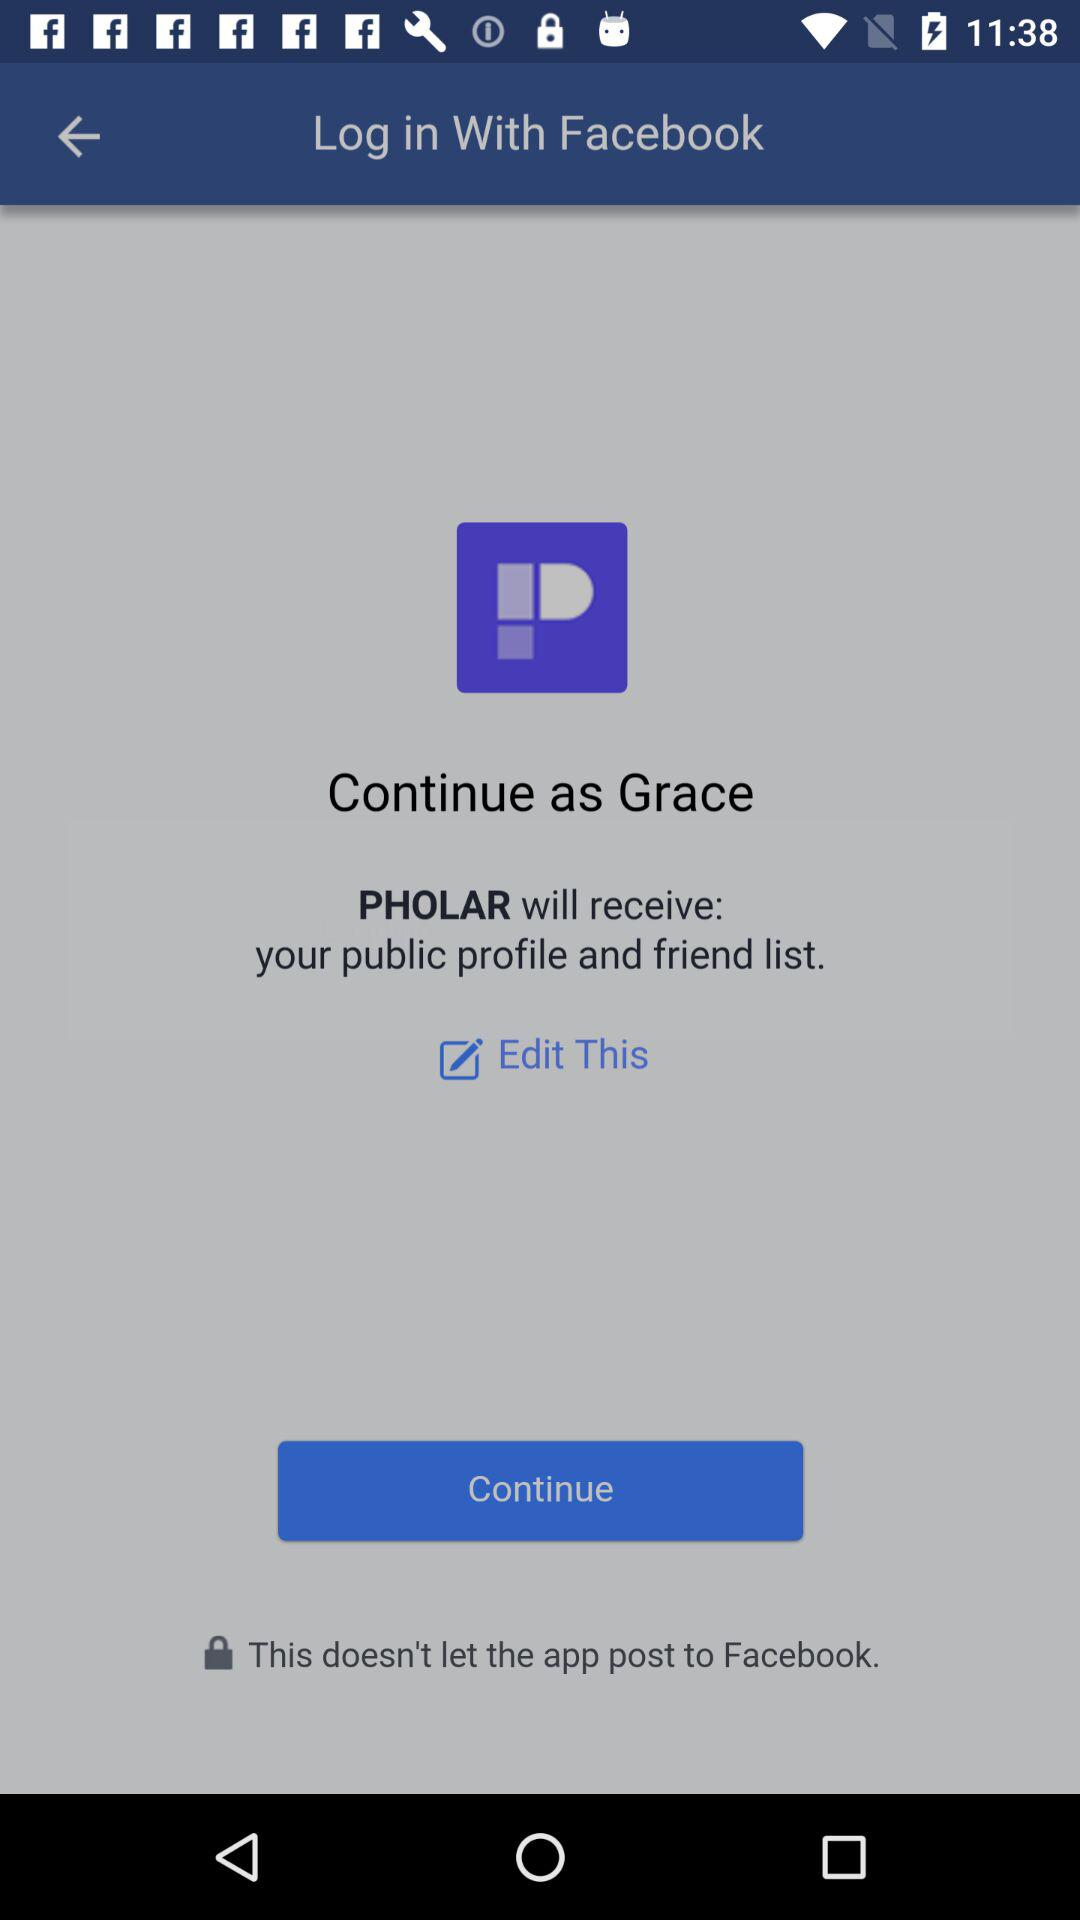Through what application can we log in? You can log in through "Facebook". 